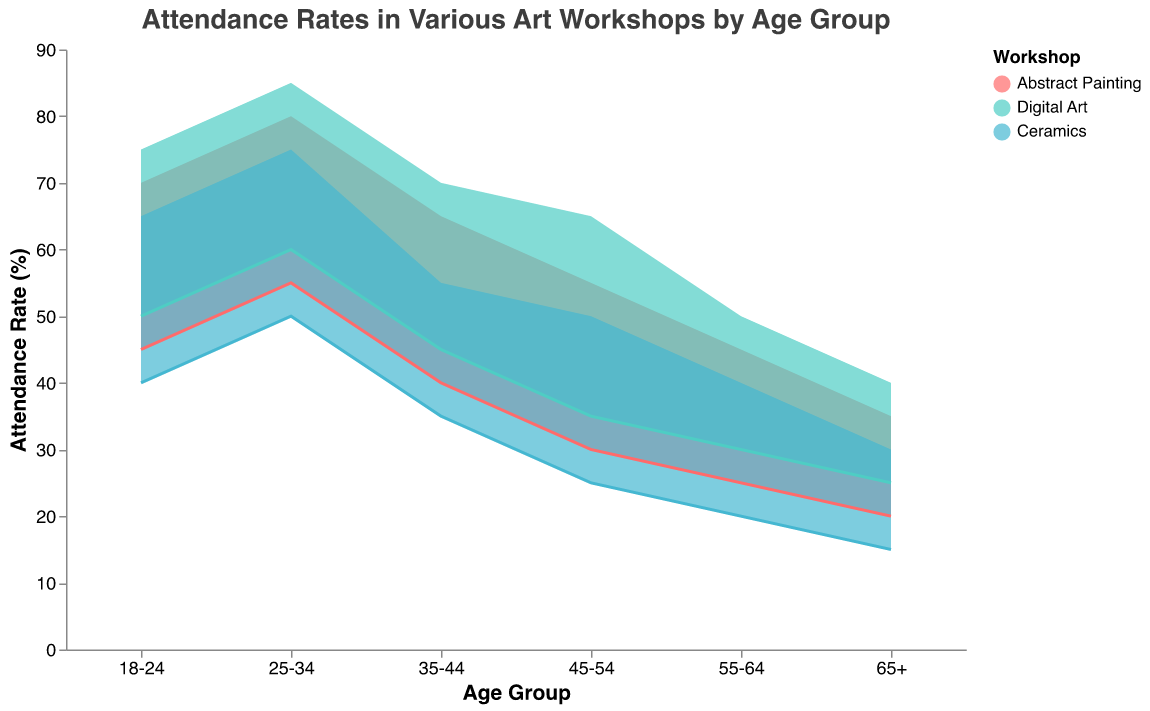What is the title of the chart? The title is usually given at the top of the chart and is often the first piece of text you would read. In this case, it mentions both the subject (Attendance Rates) and context (Various Art Workshops by Age Group).
Answer: Attendance Rates in Various Art Workshops by Age Group Which age group has the highest maximum attendance rate for Digital Art? To find this, look for the Digital Art color in the chart and identify the age group with the highest peak. Here, you'll notice that the 25-34 age group hits a maximum attendance rate of 85%.
Answer: 25-34 What is the range of attendance rates for the Ceramics workshop in the 45-54 age group? Spot the 45-54 age group, then find the range for the Ceramics color. The attendance rates vary from the minimum of 25% to the maximum of 50%.
Answer: 25% to 50% Compare the minimum attendance rates of Abstract Painting between the 18-24 and 55-64 age groups. Locate the Abstract Painting color for both the 18-24 and 55-64 age groups. The minimum attendance rate for 18-24 is 45%, and for 55-64, it is 25%. The difference is 45% - 25% = 20%.
Answer: 20% Which workshop has the smallest range of attendance rates in the 35-44 age group? Look at the 35-44 age group and check the ranges for each workshop. Abstract Painting has a range of (65-40)=25, Digital Art is (70-45)=25, and Ceramics is (55-35)=20. The smallest range is for Ceramics.
Answer: Ceramics What is the overall trend of maximum attendance rates in Abstract Painting as age groups increase? Follow the Abstract Painting color through the age groups to observe the trend. The maximum attendance rate tends to decrease: 18-24 (70%), 25-34 (80%), 35-44 (65%), 45-54 (55%), 55-64 (45%), 65+ (35%).
Answer: Decreasing How does the maximum attendance rate for Digital Art in the 65+ age group compare to Ceramics in the same age group? Look at the 65+ age group for both workshops. Digital Art has a maximum of 40%, and Ceramics has a maximum of 30%. So, Digital Art has a higher maximum attendance rate by 10%.
Answer: Digital Art is higher by 10% What is the average of the minimum attendance rates for Ceramics across all age groups? Add the minimum rates for Ceramics from all age groups: 40 + 50 + 35 + 25 + 20 + 15 = 185. There are 6 age groups, so the average is 185 / 6 ≈ 30.83%.
Answer: 30.83% Across all age groups, which workshop has the highest minimum attendance rate? Check the minimum attendance rate for each workshop in each age group. Digital Art consistently has higher minimum rates, peaking at 60% in the 25-34 group.
Answer: Digital Art What is the difference between the maximum and minimum attendance rates for Digital Art in the 18-24 age group? Find the minimum and maximum rates for Digital Art in the 18-24 group: 50% and 75%. The difference is 75% - 50% = 25%.
Answer: 25% 